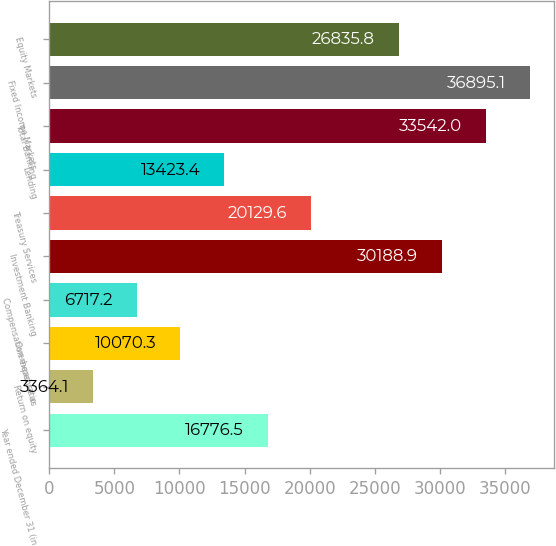Convert chart. <chart><loc_0><loc_0><loc_500><loc_500><bar_chart><fcel>Year ended December 31 (in<fcel>Return on equity<fcel>Overhead ratio<fcel>Compensation expense as<fcel>Investment Banking<fcel>Treasury Services<fcel>Lending<fcel>Total Banking<fcel>Fixed Income Markets<fcel>Equity Markets<nl><fcel>16776.5<fcel>3364.1<fcel>10070.3<fcel>6717.2<fcel>30188.9<fcel>20129.6<fcel>13423.4<fcel>33542<fcel>36895.1<fcel>26835.8<nl></chart> 